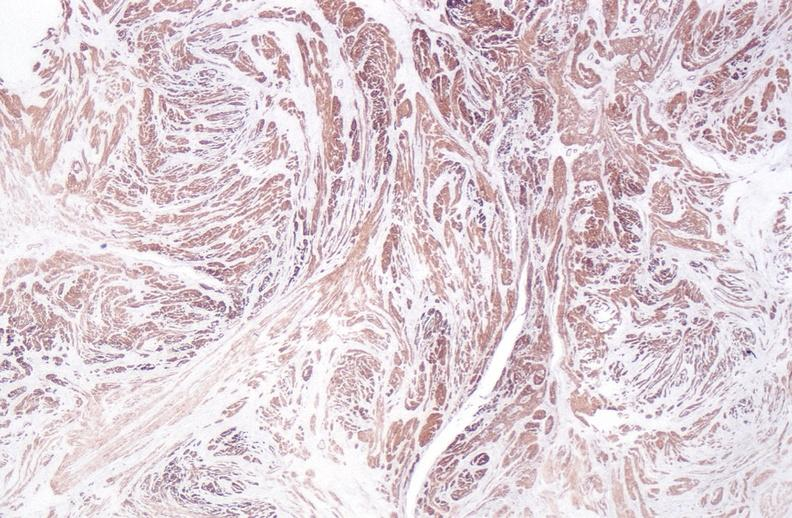do alpha smooth muscle actin immunohistochemical stain?
Answer the question using a single word or phrase. Yes 